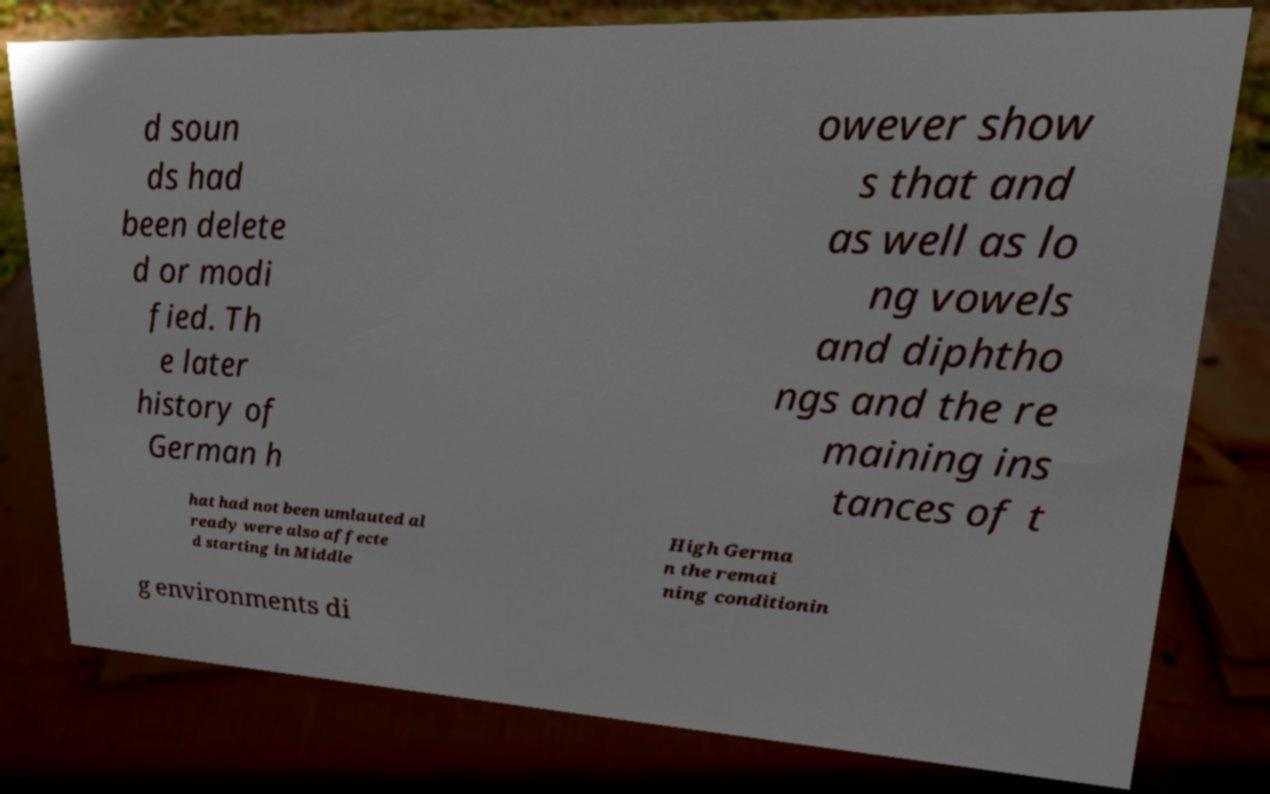Could you extract and type out the text from this image? d soun ds had been delete d or modi fied. Th e later history of German h owever show s that and as well as lo ng vowels and diphtho ngs and the re maining ins tances of t hat had not been umlauted al ready were also affecte d starting in Middle High Germa n the remai ning conditionin g environments di 